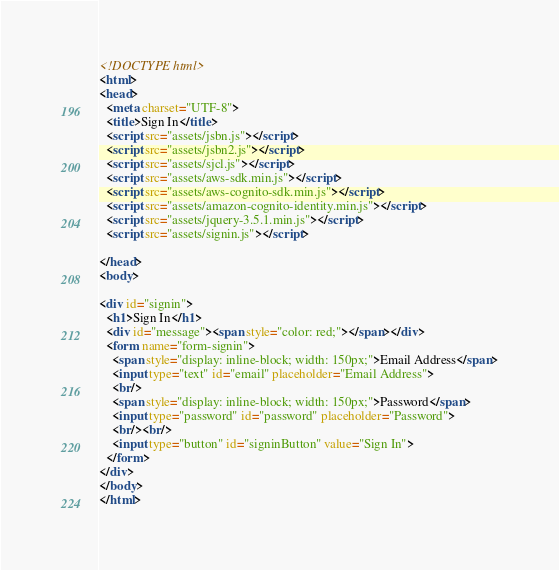<code> <loc_0><loc_0><loc_500><loc_500><_HTML_><!DOCTYPE html>
<html>
<head>
  <meta charset="UTF-8">
  <title>Sign In</title>
  <script src="assets/jsbn.js"></script>
  <script src="assets/jsbn2.js"></script>
  <script src="assets/sjcl.js"></script>
  <script src="assets/aws-sdk.min.js"></script>
  <script src="assets/aws-cognito-sdk.min.js"></script>
  <script src="assets/amazon-cognito-identity.min.js"></script>
  <script src="assets/jquery-3.5.1.min.js"></script>
  <script src="assets/signin.js"></script>

</head>
<body>

<div id="signin">
  <h1>Sign In</h1>
  <div id="message"><span style="color: red;"></span></div>
  <form name="form-signin">
    <span style="display: inline-block; width: 150px;">Email Address</span>
    <input type="text" id="email" placeholder="Email Address">
    <br/>
    <span style="display: inline-block; width: 150px;">Password</span>
    <input type="password" id="password" placeholder="Password">
    <br/><br/>
    <input type="button" id="signinButton" value="Sign In">
  </form>
</div>
</body>
</html>
</code> 